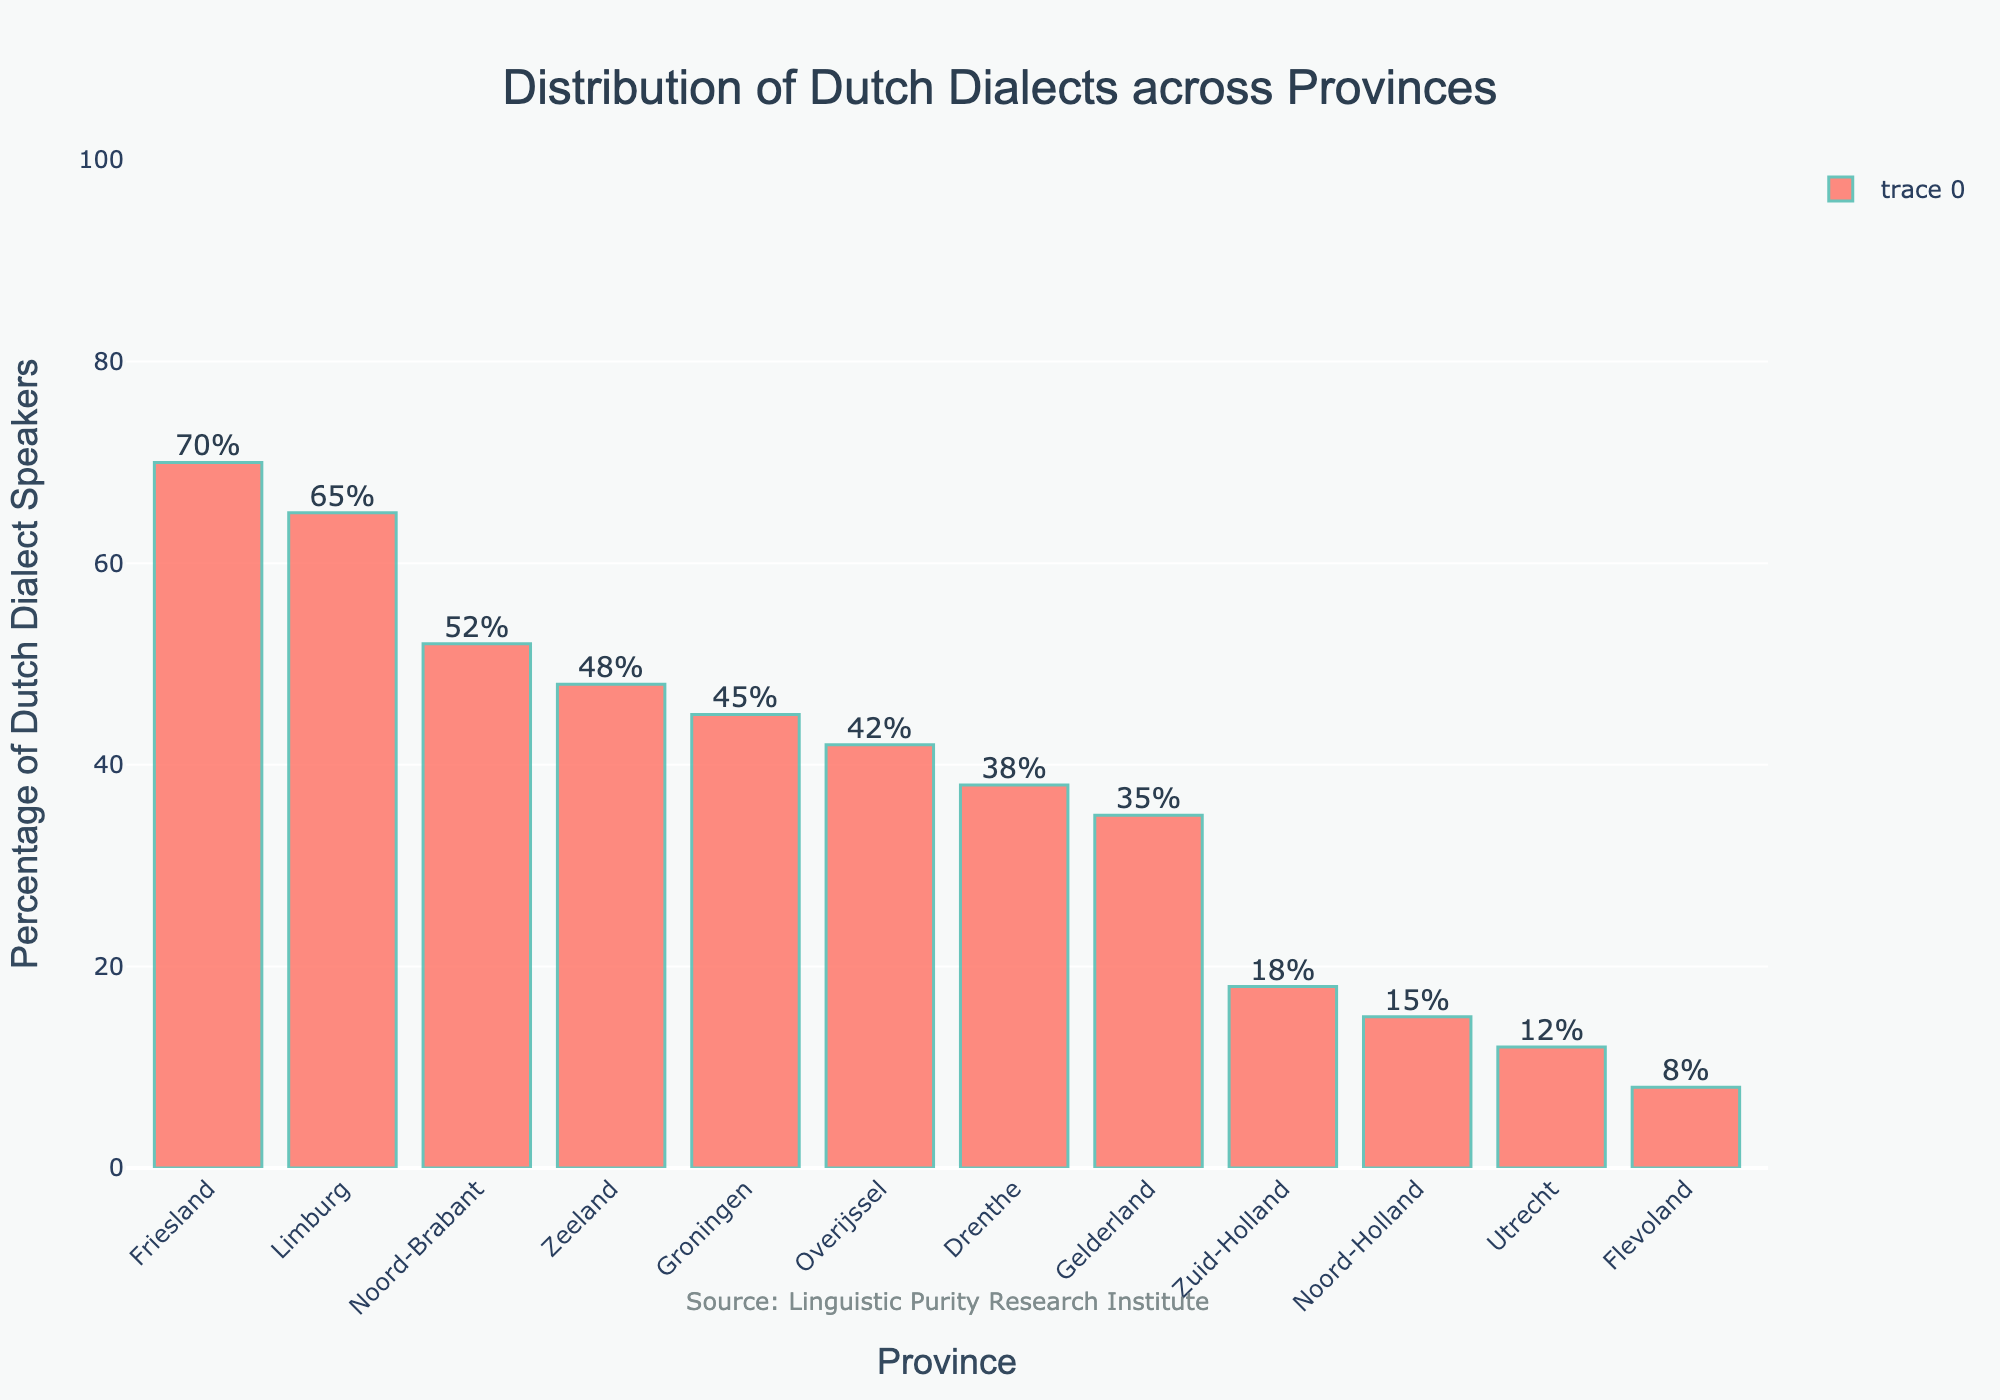Which province has the highest percentage of Dutch dialect speakers? The province with the highest bar represents the highest percentage. In the chart, Friesland has the highest bar.
Answer: Friesland What is the difference in percentage of Dutch dialect speakers between Groningen and Gelderland? Look at the heights of the bars for Groningen and Gelderland. Groningen is at 45%, and Gelderland is at 35%. The difference is 45% - 35%.
Answer: 10% Which provinces have a percentage of Dutch dialect speakers higher than 50%? Look at the bars that exceed the 50% mark. The provinces Noord-Brabant, Friesland, and Limburg have bars higher than 50%.
Answer: Noord-Brabant, Friesland, Limburg What is the average percentage of Dutch dialect speakers in Zeeland, Noord-Holland, and Drenthe? Add the percentages for Zeeland (48%), Noord-Holland (15%), and Drenthe (38%) and divide by 3. (48% + 15% + 38%) / 3 = 33.67%
Answer: 33.67% Is the percentage of Dutch dialect speakers in Utrecht more or less than half of that in Friesland? Compare the percentage in Utrecht (12%) to half the percentage in Friesland (70%). Since half of 70% is 35%, and 12% < 35%, Utrecht's percentage is less.
Answer: Less What is the sum of the percentages of Dutch dialect speakers in the three provinces with the lowest values? The three lowest values are Flevoland (8%), Utrecht (12%), and Noord-Holland (15%). Sum these percentages: 8% + 12% + 15% = 35%.
Answer: 35% Which province shows a percentage of Dutch dialect speakers closest to 40%? Identify the bars around the 40% mark. Overijssel has 42%, Drenthe has 38%, and Groningen has 45%. Drenthe at 38% is the closest.
Answer: Drenthe What is the median percentage of Dutch dialect speakers across all provinces? Arrange all percentages in ascending order: 8%, 12%, 15%, 18%, 35%, 38%, 42%, 45%, 48%, 52%, 65%, 70%. With 12 data points, the median is the average of the 6th and 7th values: (38% + 42%) / 2 = 40%.
Answer: 40% Which has more Dutch dialect speakers, Limburg or the combined total of Flevoland and Utrecht? Limburg has 65%. Combined Flevoland (8%) and Utrecht (12%) total 8% + 12% = 20%. Limburg's percentage is greater.
Answer: Limburg 